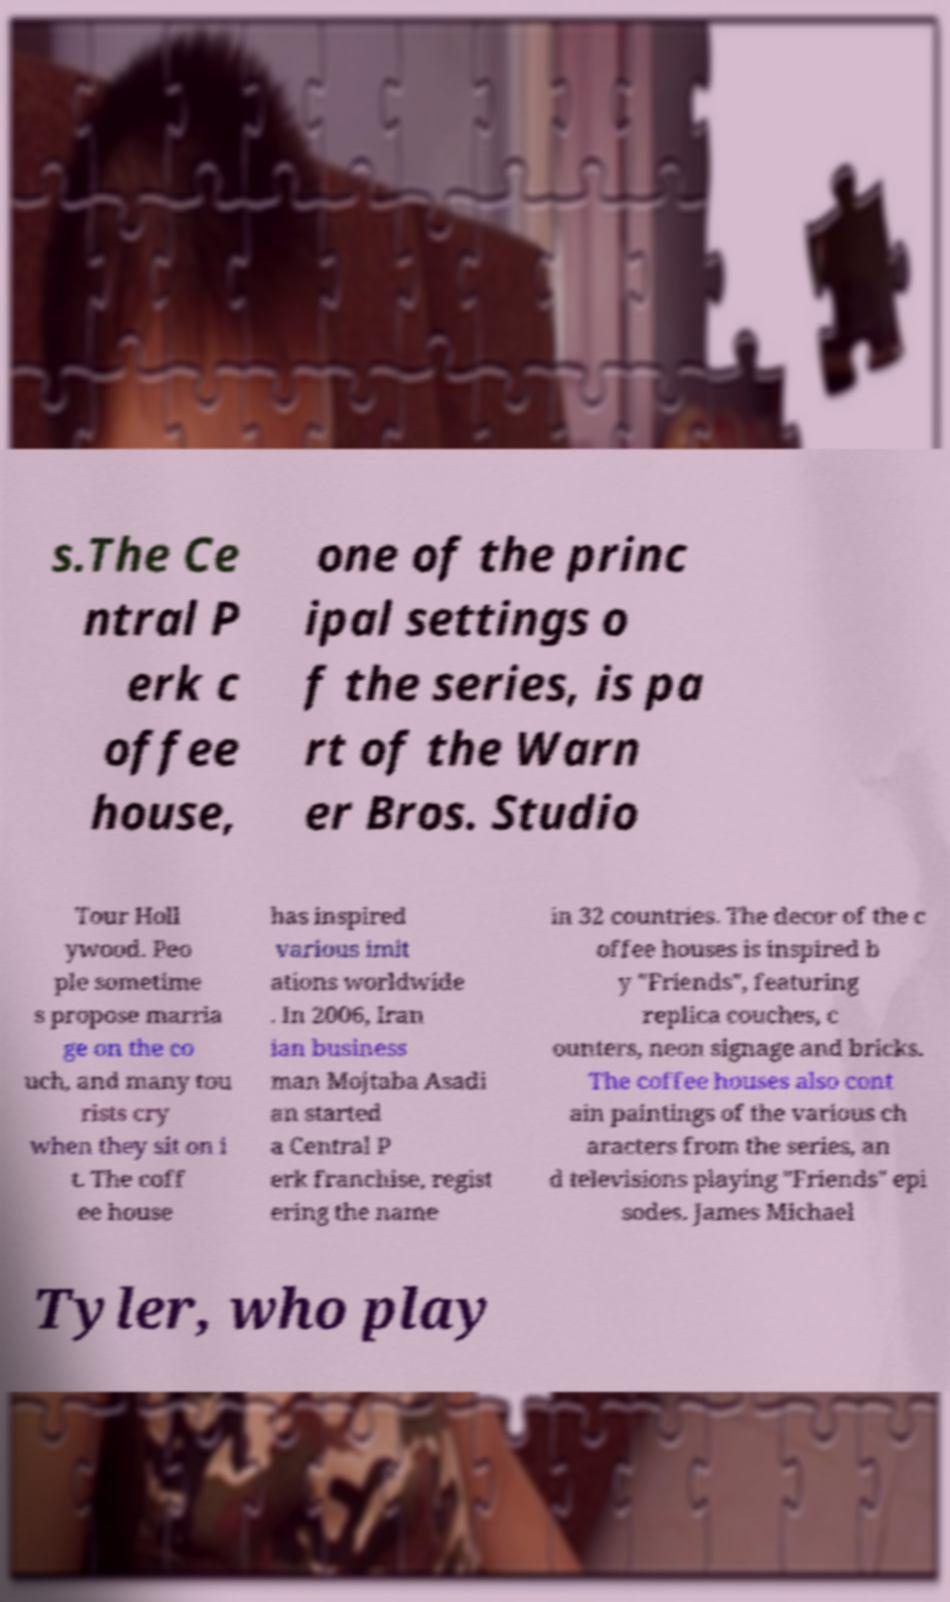There's text embedded in this image that I need extracted. Can you transcribe it verbatim? s.The Ce ntral P erk c offee house, one of the princ ipal settings o f the series, is pa rt of the Warn er Bros. Studio Tour Holl ywood. Peo ple sometime s propose marria ge on the co uch, and many tou rists cry when they sit on i t. The coff ee house has inspired various imit ations worldwide . In 2006, Iran ian business man Mojtaba Asadi an started a Central P erk franchise, regist ering the name in 32 countries. The decor of the c offee houses is inspired b y "Friends", featuring replica couches, c ounters, neon signage and bricks. The coffee houses also cont ain paintings of the various ch aracters from the series, an d televisions playing "Friends" epi sodes. James Michael Tyler, who play 